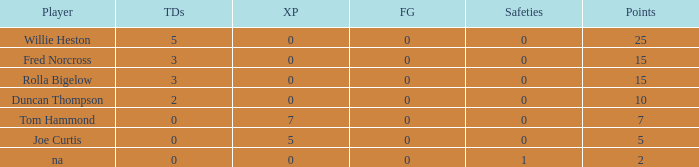Which Points is the lowest one that has Touchdowns smaller than 2, and an Extra points of 7, and a Field goals smaller than 0? None. 